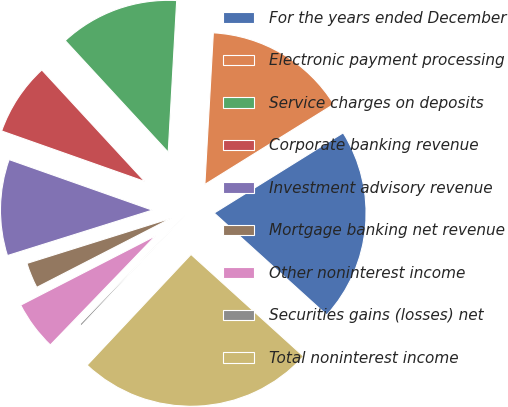<chart> <loc_0><loc_0><loc_500><loc_500><pie_chart><fcel>For the years ended December<fcel>Electronic payment processing<fcel>Service charges on deposits<fcel>Corporate banking revenue<fcel>Investment advisory revenue<fcel>Mortgage banking net revenue<fcel>Other noninterest income<fcel>Securities gains (losses) net<fcel>Total noninterest income<nl><fcel>20.57%<fcel>15.26%<fcel>12.75%<fcel>7.74%<fcel>10.24%<fcel>2.72%<fcel>5.23%<fcel>0.22%<fcel>25.28%<nl></chart> 